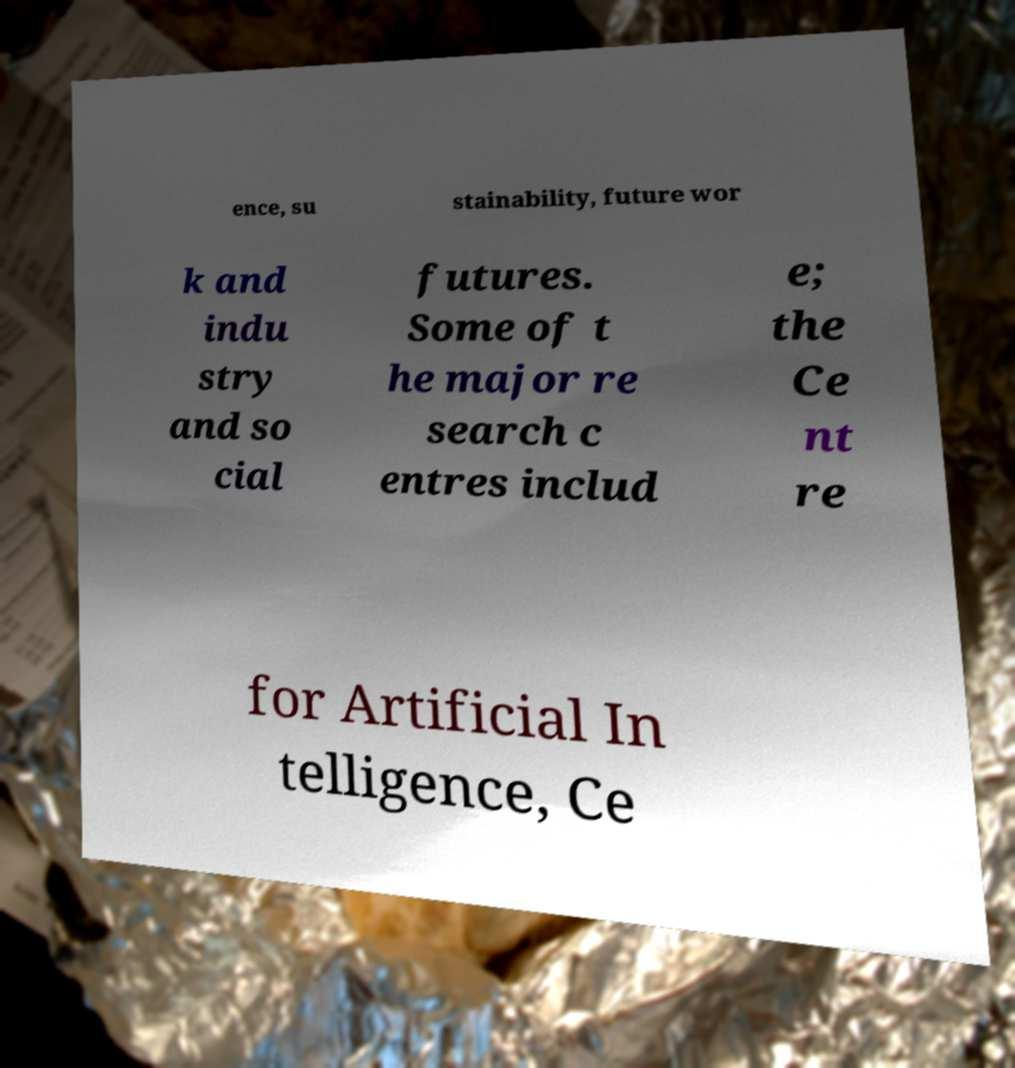What messages or text are displayed in this image? I need them in a readable, typed format. ence, su stainability, future wor k and indu stry and so cial futures. Some of t he major re search c entres includ e; the Ce nt re for Artificial In telligence, Ce 